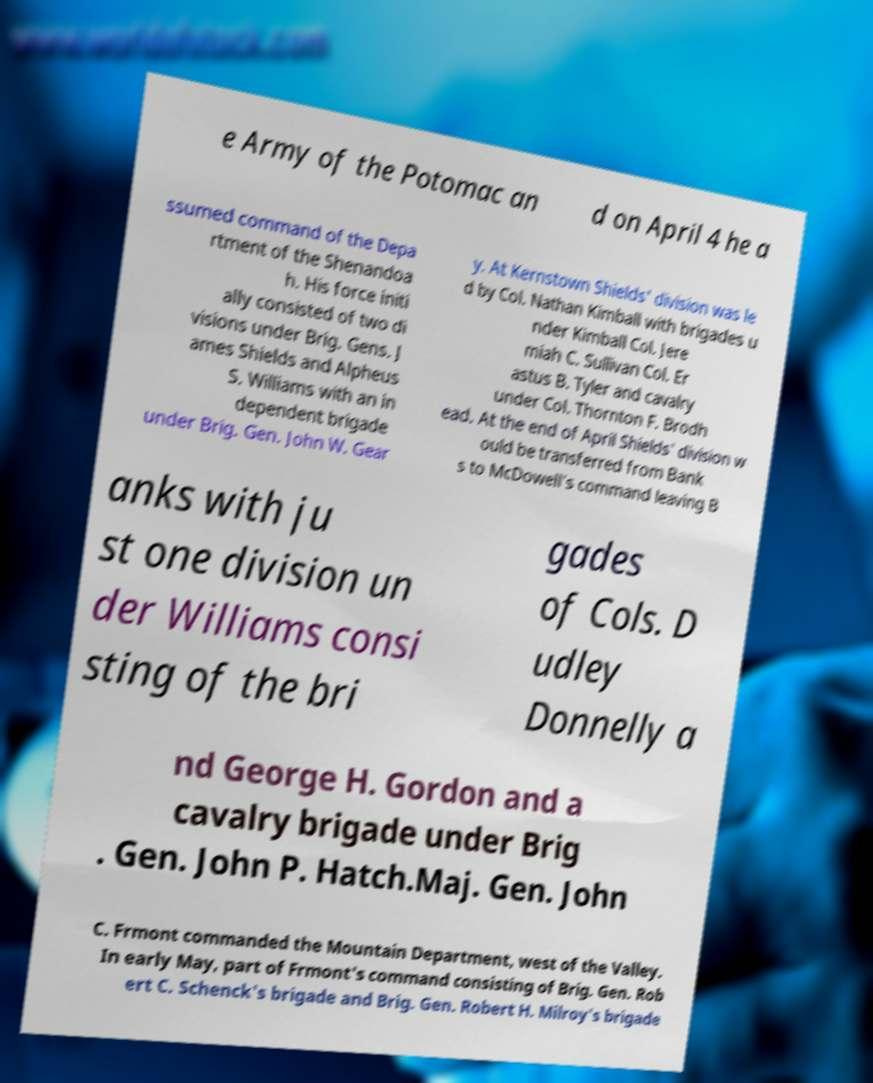Please identify and transcribe the text found in this image. e Army of the Potomac an d on April 4 he a ssumed command of the Depa rtment of the Shenandoa h. His force initi ally consisted of two di visions under Brig. Gens. J ames Shields and Alpheus S. Williams with an in dependent brigade under Brig. Gen. John W. Gear y. At Kernstown Shields' division was le d by Col. Nathan Kimball with brigades u nder Kimball Col. Jere miah C. Sullivan Col. Er astus B. Tyler and cavalry under Col. Thornton F. Brodh ead. At the end of April Shields' division w ould be transferred from Bank s to McDowell's command leaving B anks with ju st one division un der Williams consi sting of the bri gades of Cols. D udley Donnelly a nd George H. Gordon and a cavalry brigade under Brig . Gen. John P. Hatch.Maj. Gen. John C. Frmont commanded the Mountain Department, west of the Valley. In early May, part of Frmont's command consisting of Brig. Gen. Rob ert C. Schenck's brigade and Brig. Gen. Robert H. Milroy's brigade 